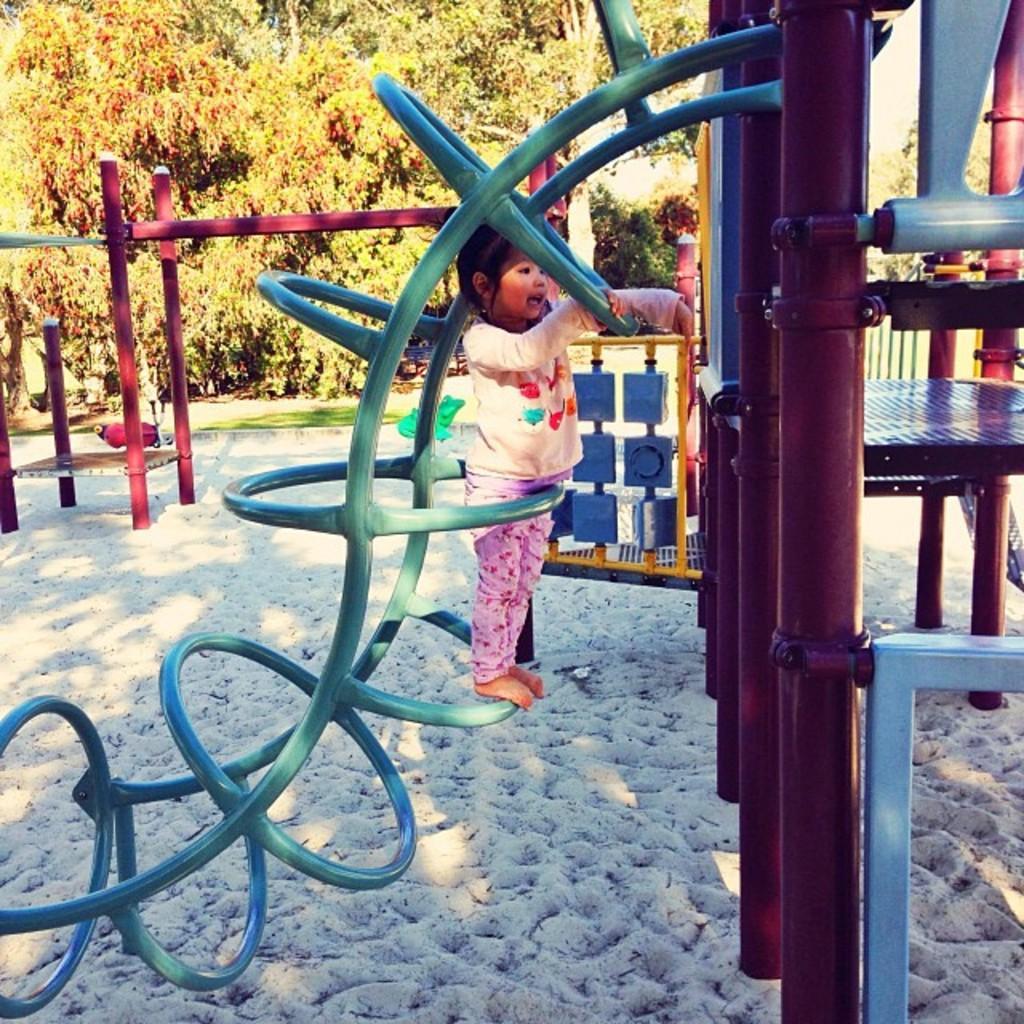Can you describe this image briefly? In this image there is a kids playing zone in the garden. In the front we can see small girl climbing on the pipes. Behind there are some trees. 